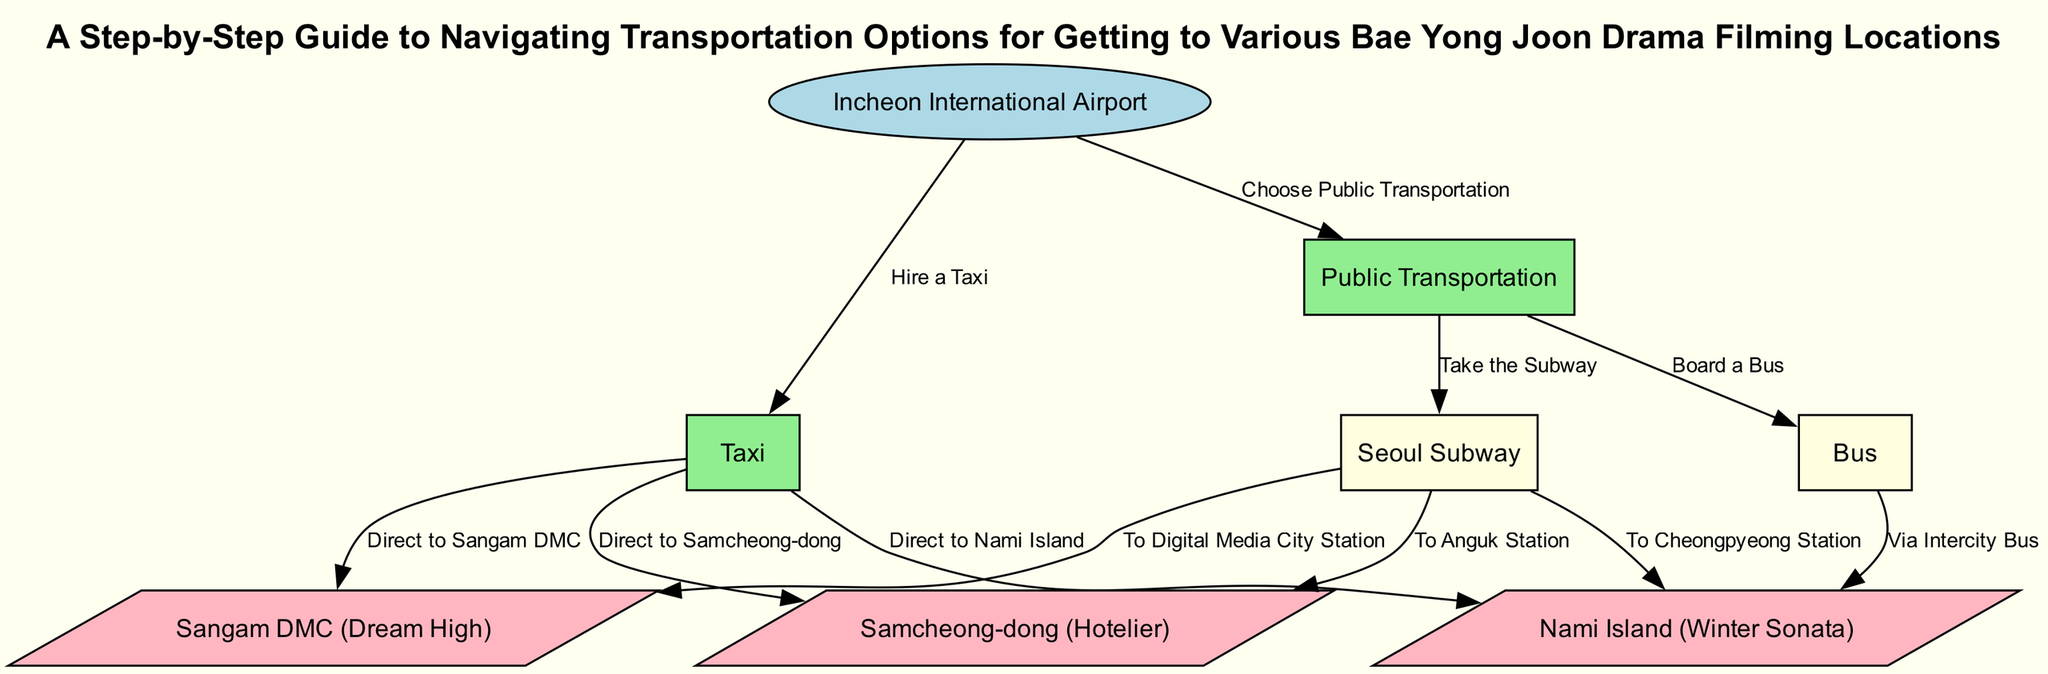What is the starting point in the diagram? The diagram specifies that the starting point is "Incheon International Airport" as indicated by the node type "start."
Answer: Incheon International Airport How many locations are listed in the diagram? By counting the nodes under the type "location," there are three distinct locations presented: Nami Island, Samcheong-dong, and Sangam DMC.
Answer: 3 Which transportation option leads directly to Sangam DMC? The diagram indicates that if a taxi is chosen, it directly leads to Sangam DMC according to the edge connecting these two nodes.
Answer: Taxi Which station must you reach to visit Nami Island using the subway? The edge from the subway to Nami Island highlights the connection through Cheongpyeong Station, meaning you must take the subway to this station first.
Answer: Cheongpyeong Station If you choose public transportation, which subcategory must you select first? The diagram shows that upon choosing public transportation, the first options available are either taking the subway or boarding a bus, thus indicating the need to choose between these two subcategories first.
Answer: Subway or Bus What type of transportation allows direct access to Samcheong-dong? The diagram shows that taxis and trains both provide direct routes to Samcheong-dong, indicating a variety of transport options to this location.
Answer: Taxi How many edges are there in the diagram? By counting all the connections (edges) formed between nodes, we can see there are a total of eight edges connecting different transport options and locations.
Answer: 8 What color represents public transportation in the diagram? Each category in the diagram is color-coded, with public transportation depicted in light green to differentiate it from other transport options.
Answer: Light green What choice do you have after arriving at Incheon International Airport? After arriving at the airport, the diagram presents two primary choices for transportation: either opting for public transportation or hiring a taxi, clearly defining these available options.
Answer: Public transportation or Taxi 